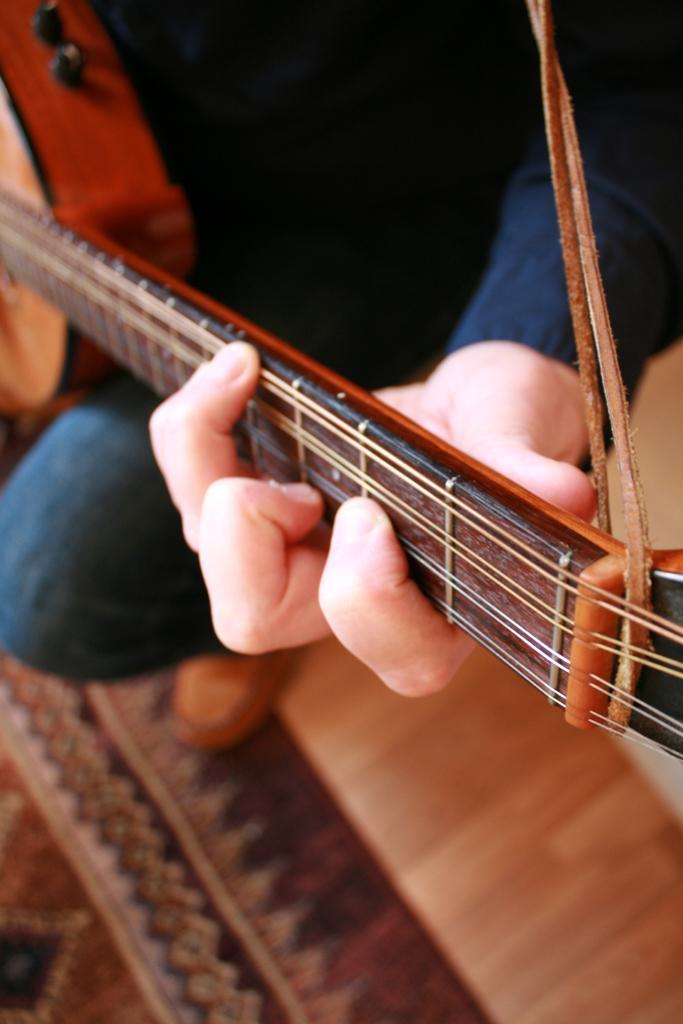Describe this image in one or two sentences. In this image, there is a person wearing clothes and playing a guitar. 